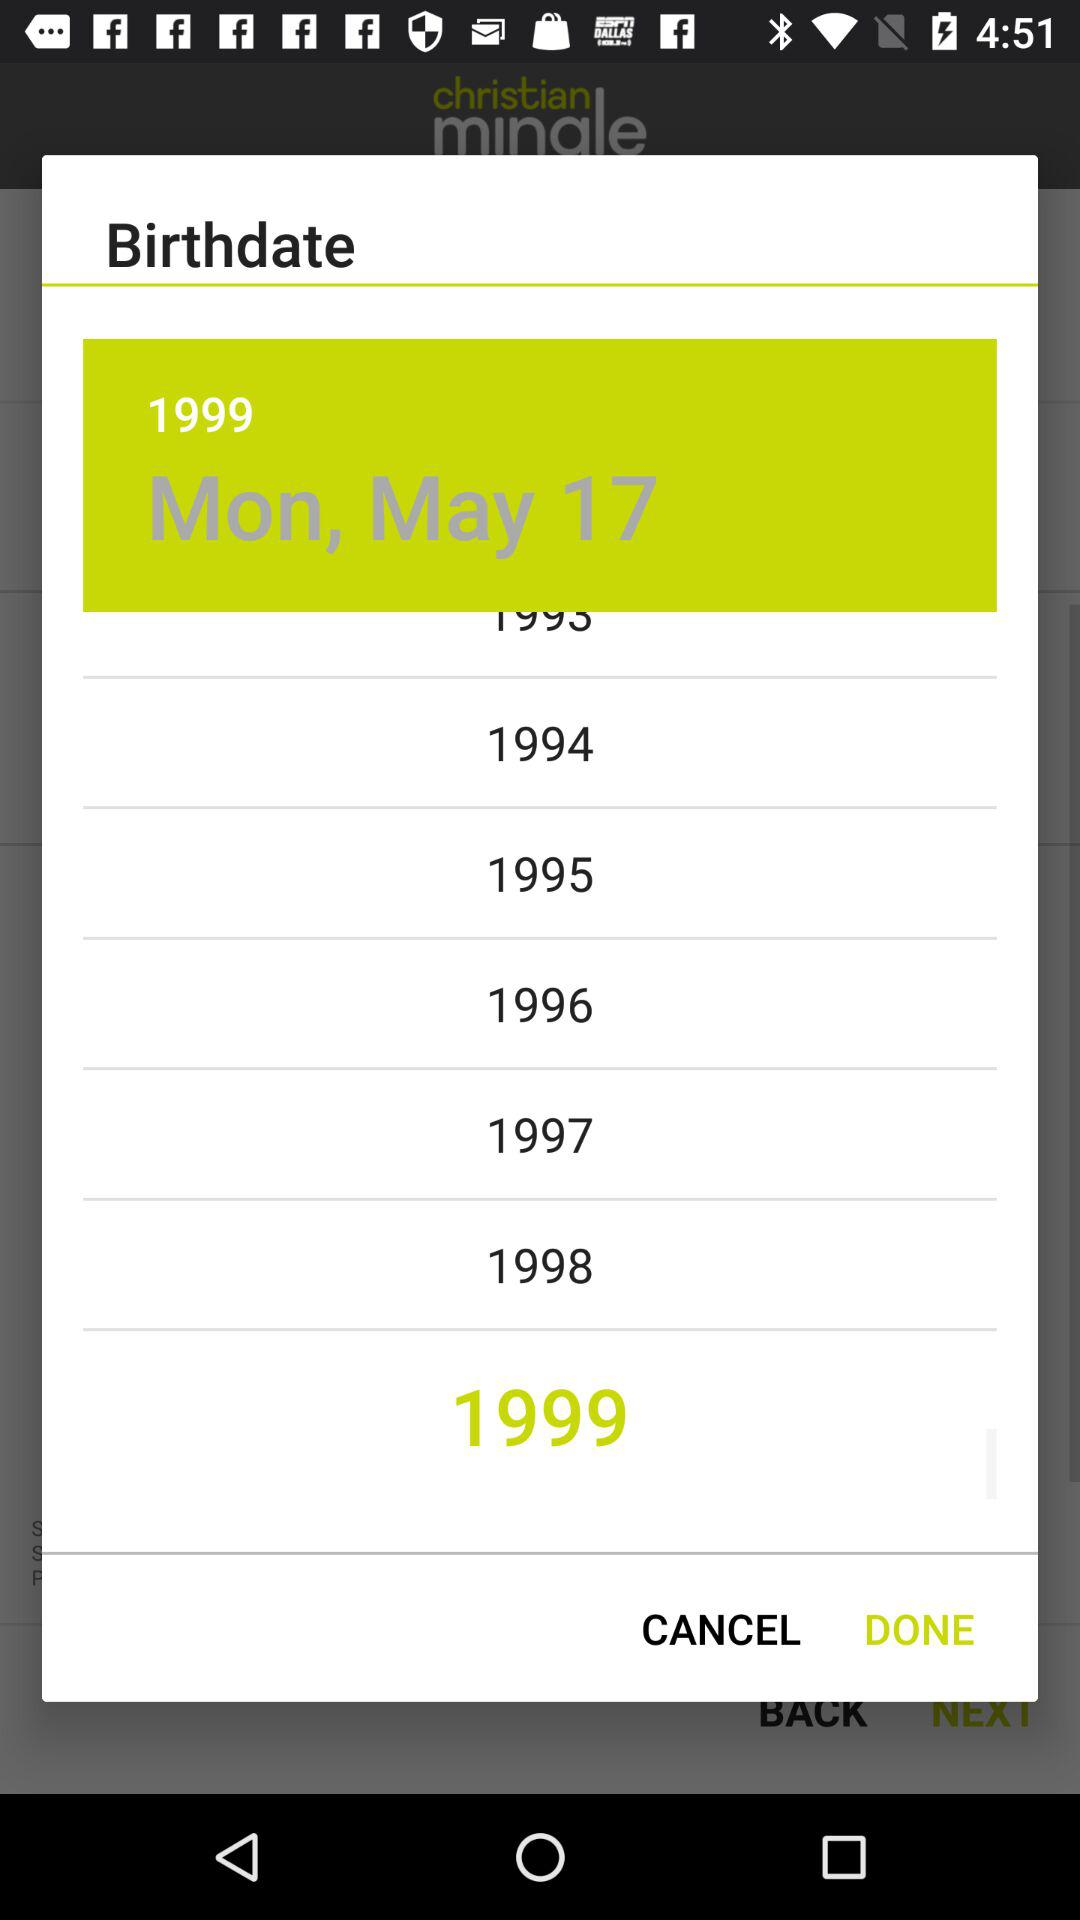What is the day on May 17? The day is Monday. 